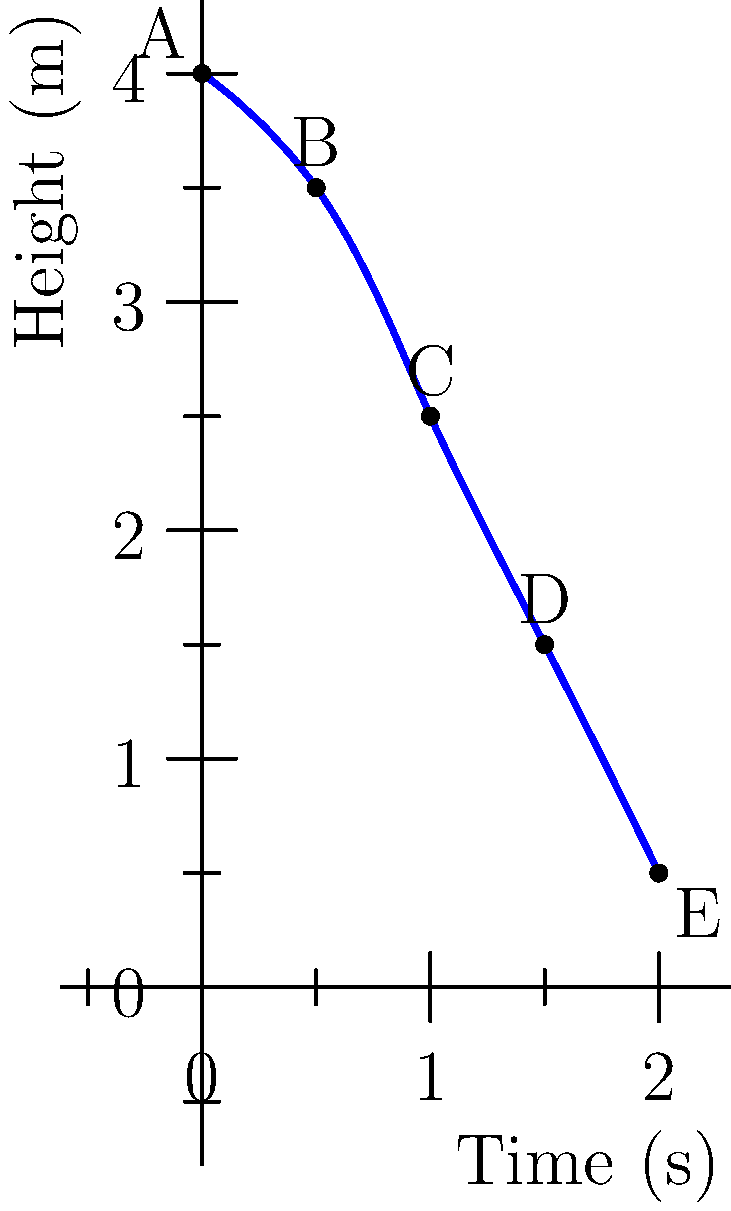Based on the sequential body poses of a gymnast during a dismount, as shown in the graph, which machine learning model would be most suitable for predicting the final landing position (point E)? Consider that we have data for multiple dismounts with various landing positions. To predict the final landing position of a gymnast during a dismount, we need to consider the following factors:

1. Sequential nature of the data: The poses are in a specific order, representing the gymnast's movement over time.

2. Continuous output: The landing position (x and y coordinates) is a continuous value.

3. Time-series data: The poses are recorded at different time points during the dismount.

4. Non-linear relationships: The relationship between the sequential poses and the final landing position is likely non-linear.

Given these considerations, the most suitable machine learning model would be a Recurrent Neural Network (RNN), specifically a Long Short-Term Memory (LSTM) network. Here's why:

1. RNNs are designed to handle sequential data, making them ideal for processing the series of poses.

2. LSTMs, a type of RNN, are particularly good at capturing long-term dependencies in sequences, which is crucial for predicting the final landing position based on earlier poses.

3. LSTMs can output continuous values, suitable for predicting x and y coordinates of the landing position.

4. They can capture non-linear relationships between the input (poses) and output (landing position).

5. LSTMs are effective in handling time-series data, which aligns with the nature of the dismount sequence.

6. They can be trained on multiple dismount sequences, learning patterns that generalize well to new dismounts.

Other models like simple feedforward neural networks or linear regression would be less suitable as they don't inherently account for the sequential nature of the data. Support Vector Machines (SVMs) or Random Forests could potentially be used but would require careful feature engineering to capture the temporal aspects of the data.
Answer: Long Short-Term Memory (LSTM) network 